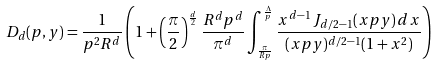<formula> <loc_0><loc_0><loc_500><loc_500>D _ { d } ( p , y ) = \frac { 1 } { p ^ { 2 } R ^ { d } } \left ( 1 + \left ( \frac { \pi } { 2 } \right ) ^ { \frac { d } { 2 } } \frac { R ^ { d } p ^ { d } } { \pi ^ { d } } \int _ { \frac { \pi } { R p } } ^ { \frac { \Lambda } { p } } \frac { x ^ { d - 1 } \, J _ { d / 2 - 1 } ( x p y ) \, d x } { ( x p y ) ^ { d / 2 - 1 } ( 1 + x ^ { 2 } ) } \right )</formula> 